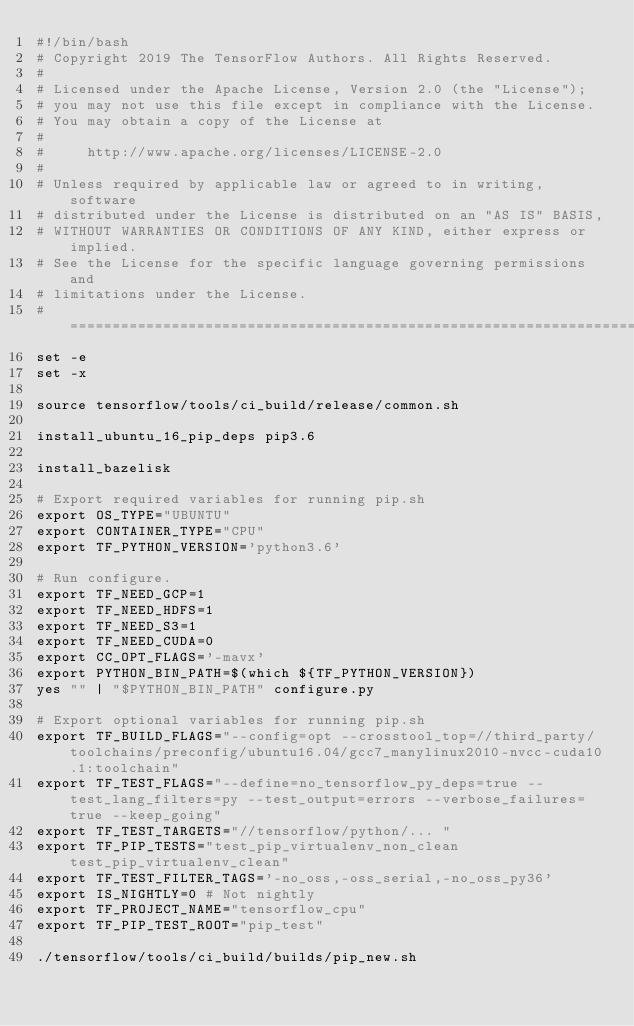<code> <loc_0><loc_0><loc_500><loc_500><_Bash_>#!/bin/bash
# Copyright 2019 The TensorFlow Authors. All Rights Reserved.
#
# Licensed under the Apache License, Version 2.0 (the "License");
# you may not use this file except in compliance with the License.
# You may obtain a copy of the License at
#
#     http://www.apache.org/licenses/LICENSE-2.0
#
# Unless required by applicable law or agreed to in writing, software
# distributed under the License is distributed on an "AS IS" BASIS,
# WITHOUT WARRANTIES OR CONDITIONS OF ANY KIND, either express or implied.
# See the License for the specific language governing permissions and
# limitations under the License.
# ==============================================================================
set -e
set -x

source tensorflow/tools/ci_build/release/common.sh

install_ubuntu_16_pip_deps pip3.6

install_bazelisk

# Export required variables for running pip.sh
export OS_TYPE="UBUNTU"
export CONTAINER_TYPE="CPU"
export TF_PYTHON_VERSION='python3.6'

# Run configure.
export TF_NEED_GCP=1
export TF_NEED_HDFS=1
export TF_NEED_S3=1
export TF_NEED_CUDA=0
export CC_OPT_FLAGS='-mavx'
export PYTHON_BIN_PATH=$(which ${TF_PYTHON_VERSION})
yes "" | "$PYTHON_BIN_PATH" configure.py

# Export optional variables for running pip.sh
export TF_BUILD_FLAGS="--config=opt --crosstool_top=//third_party/toolchains/preconfig/ubuntu16.04/gcc7_manylinux2010-nvcc-cuda10.1:toolchain"
export TF_TEST_FLAGS="--define=no_tensorflow_py_deps=true --test_lang_filters=py --test_output=errors --verbose_failures=true --keep_going"
export TF_TEST_TARGETS="//tensorflow/python/... "
export TF_PIP_TESTS="test_pip_virtualenv_non_clean test_pip_virtualenv_clean"
export TF_TEST_FILTER_TAGS='-no_oss,-oss_serial,-no_oss_py36'
export IS_NIGHTLY=0 # Not nightly
export TF_PROJECT_NAME="tensorflow_cpu"
export TF_PIP_TEST_ROOT="pip_test"

./tensorflow/tools/ci_build/builds/pip_new.sh
</code> 